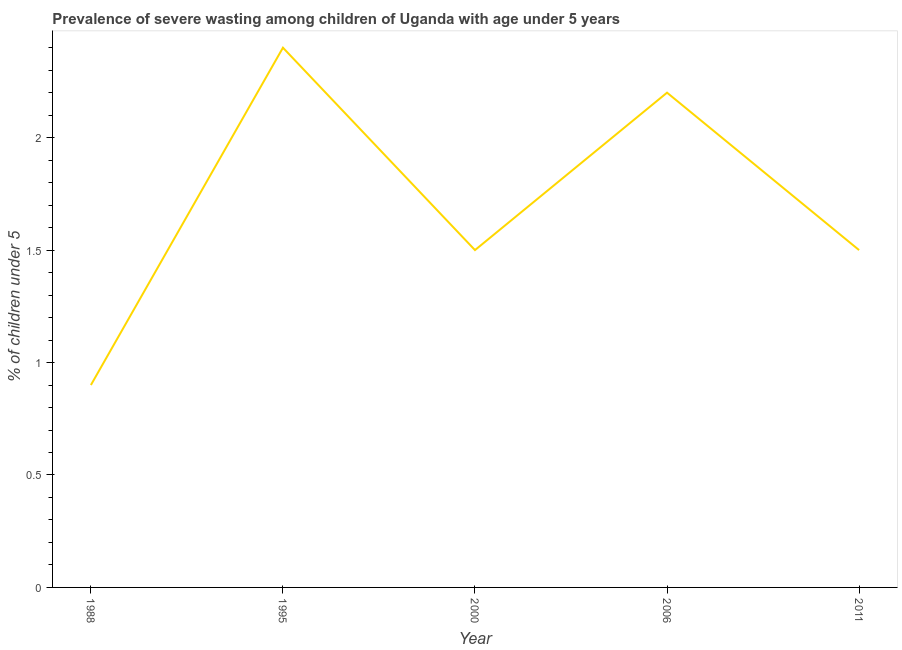What is the prevalence of severe wasting in 1995?
Offer a very short reply. 2.4. Across all years, what is the maximum prevalence of severe wasting?
Your answer should be very brief. 2.4. Across all years, what is the minimum prevalence of severe wasting?
Ensure brevity in your answer.  0.9. What is the sum of the prevalence of severe wasting?
Provide a succinct answer. 8.5. What is the difference between the prevalence of severe wasting in 2006 and 2011?
Ensure brevity in your answer.  0.7. What is the average prevalence of severe wasting per year?
Offer a very short reply. 1.7. What is the median prevalence of severe wasting?
Make the answer very short. 1.5. What is the ratio of the prevalence of severe wasting in 2000 to that in 2006?
Give a very brief answer. 0.68. Is the prevalence of severe wasting in 1995 less than that in 2006?
Offer a terse response. No. What is the difference between the highest and the second highest prevalence of severe wasting?
Give a very brief answer. 0.2. What is the difference between the highest and the lowest prevalence of severe wasting?
Provide a short and direct response. 1.5. In how many years, is the prevalence of severe wasting greater than the average prevalence of severe wasting taken over all years?
Offer a very short reply. 2. Does the prevalence of severe wasting monotonically increase over the years?
Offer a very short reply. No. How many years are there in the graph?
Ensure brevity in your answer.  5. What is the difference between two consecutive major ticks on the Y-axis?
Provide a short and direct response. 0.5. Are the values on the major ticks of Y-axis written in scientific E-notation?
Your answer should be very brief. No. Does the graph contain any zero values?
Offer a terse response. No. Does the graph contain grids?
Ensure brevity in your answer.  No. What is the title of the graph?
Your response must be concise. Prevalence of severe wasting among children of Uganda with age under 5 years. What is the label or title of the Y-axis?
Provide a succinct answer.  % of children under 5. What is the  % of children under 5 in 1988?
Make the answer very short. 0.9. What is the  % of children under 5 in 1995?
Provide a succinct answer. 2.4. What is the  % of children under 5 in 2006?
Your response must be concise. 2.2. What is the difference between the  % of children under 5 in 1988 and 1995?
Your response must be concise. -1.5. What is the difference between the  % of children under 5 in 1988 and 2000?
Provide a succinct answer. -0.6. What is the difference between the  % of children under 5 in 1988 and 2006?
Ensure brevity in your answer.  -1.3. What is the difference between the  % of children under 5 in 1988 and 2011?
Offer a very short reply. -0.6. What is the difference between the  % of children under 5 in 1995 and 2006?
Provide a short and direct response. 0.2. What is the difference between the  % of children under 5 in 2000 and 2006?
Give a very brief answer. -0.7. What is the difference between the  % of children under 5 in 2000 and 2011?
Your answer should be very brief. 0. What is the difference between the  % of children under 5 in 2006 and 2011?
Offer a very short reply. 0.7. What is the ratio of the  % of children under 5 in 1988 to that in 1995?
Keep it short and to the point. 0.38. What is the ratio of the  % of children under 5 in 1988 to that in 2006?
Provide a short and direct response. 0.41. What is the ratio of the  % of children under 5 in 1995 to that in 2000?
Provide a short and direct response. 1.6. What is the ratio of the  % of children under 5 in 1995 to that in 2006?
Make the answer very short. 1.09. What is the ratio of the  % of children under 5 in 1995 to that in 2011?
Your answer should be very brief. 1.6. What is the ratio of the  % of children under 5 in 2000 to that in 2006?
Your answer should be compact. 0.68. What is the ratio of the  % of children under 5 in 2006 to that in 2011?
Your answer should be very brief. 1.47. 